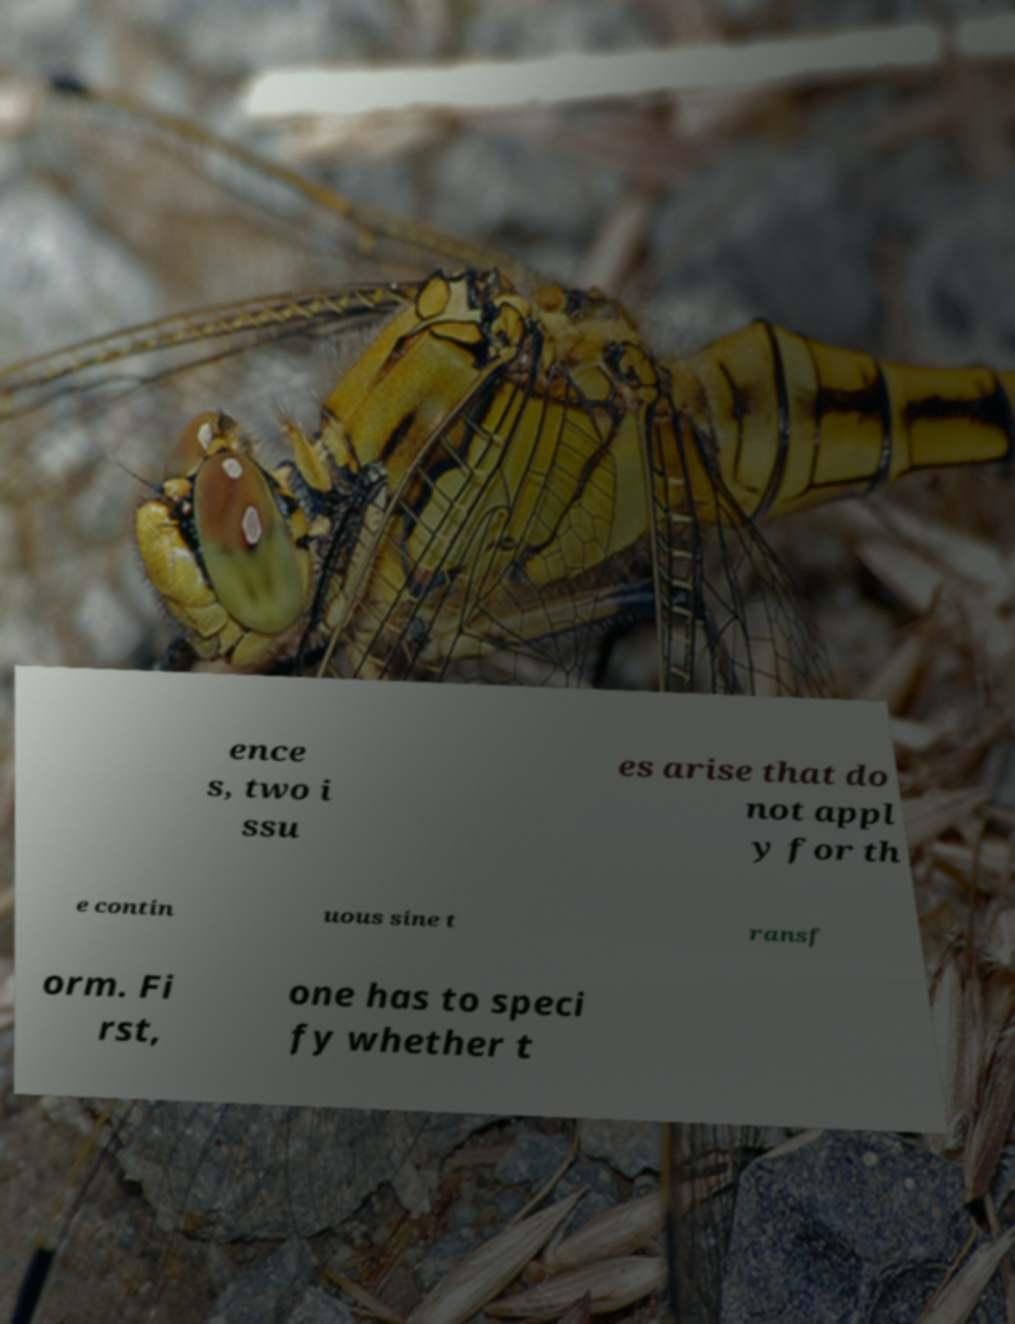Can you accurately transcribe the text from the provided image for me? ence s, two i ssu es arise that do not appl y for th e contin uous sine t ransf orm. Fi rst, one has to speci fy whether t 